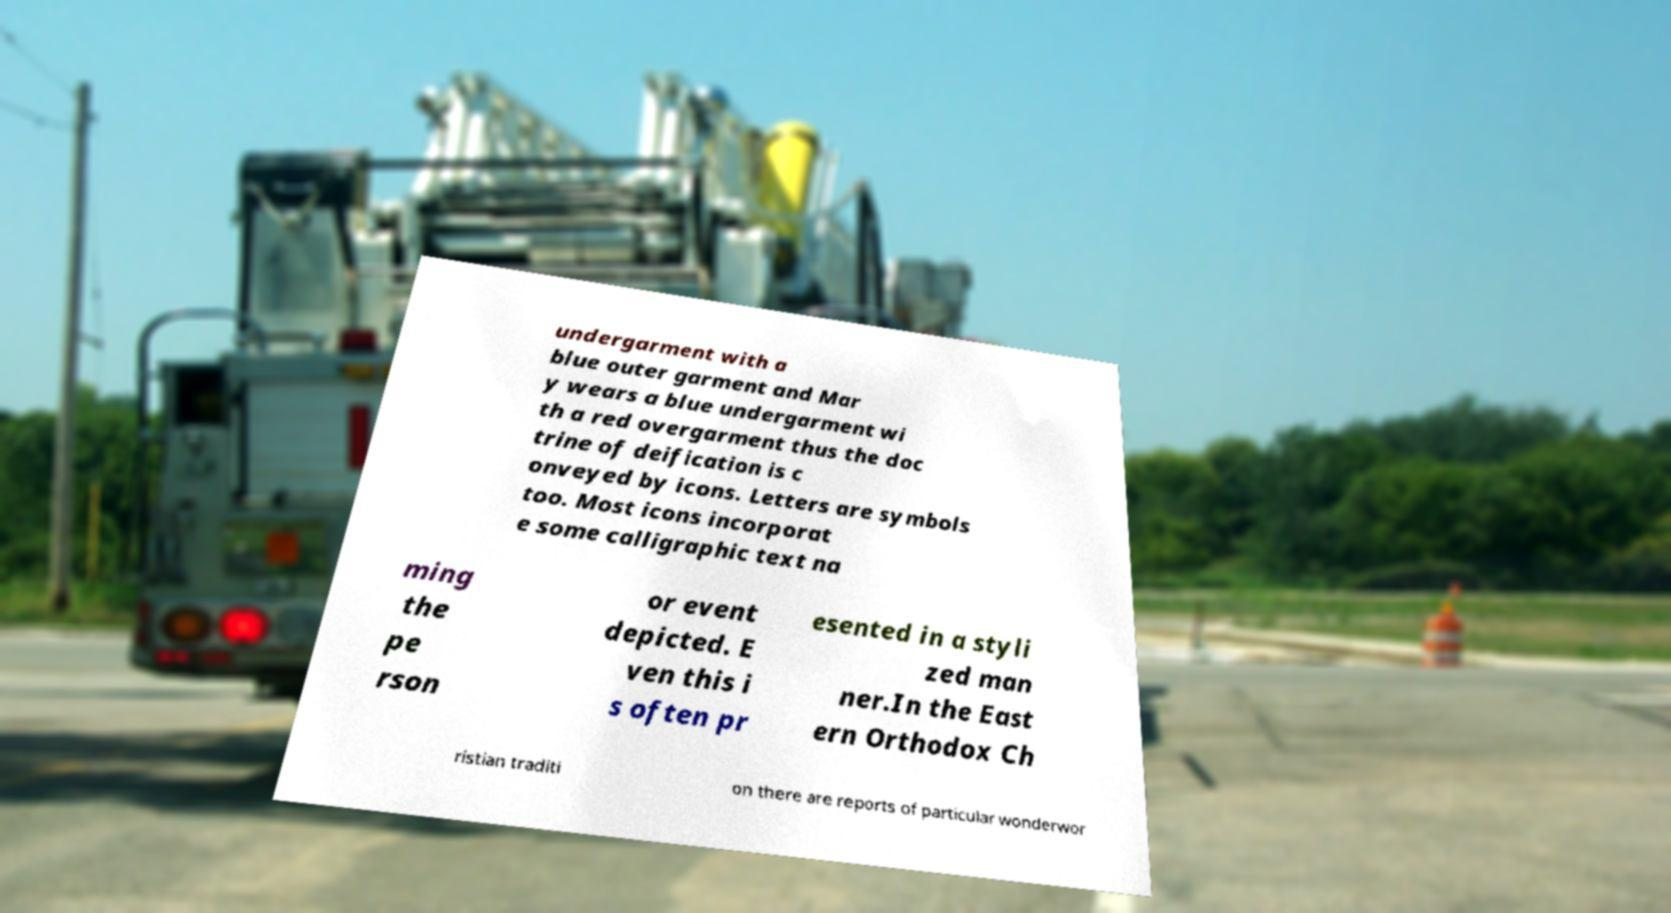Please identify and transcribe the text found in this image. undergarment with a blue outer garment and Mar y wears a blue undergarment wi th a red overgarment thus the doc trine of deification is c onveyed by icons. Letters are symbols too. Most icons incorporat e some calligraphic text na ming the pe rson or event depicted. E ven this i s often pr esented in a styli zed man ner.In the East ern Orthodox Ch ristian traditi on there are reports of particular wonderwor 